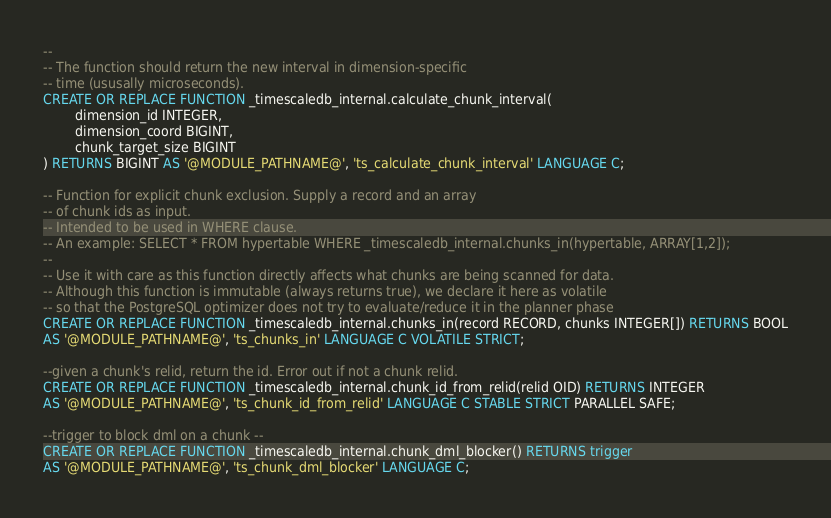<code> <loc_0><loc_0><loc_500><loc_500><_SQL_>--
-- The function should return the new interval in dimension-specific
-- time (ususally microseconds).
CREATE OR REPLACE FUNCTION _timescaledb_internal.calculate_chunk_interval(
        dimension_id INTEGER,
        dimension_coord BIGINT,
        chunk_target_size BIGINT
) RETURNS BIGINT AS '@MODULE_PATHNAME@', 'ts_calculate_chunk_interval' LANGUAGE C;

-- Function for explicit chunk exclusion. Supply a record and an array
-- of chunk ids as input.
-- Intended to be used in WHERE clause.
-- An example: SELECT * FROM hypertable WHERE _timescaledb_internal.chunks_in(hypertable, ARRAY[1,2]);
--
-- Use it with care as this function directly affects what chunks are being scanned for data.
-- Although this function is immutable (always returns true), we declare it here as volatile
-- so that the PostgreSQL optimizer does not try to evaluate/reduce it in the planner phase
CREATE OR REPLACE FUNCTION _timescaledb_internal.chunks_in(record RECORD, chunks INTEGER[]) RETURNS BOOL
AS '@MODULE_PATHNAME@', 'ts_chunks_in' LANGUAGE C VOLATILE STRICT;

--given a chunk's relid, return the id. Error out if not a chunk relid.
CREATE OR REPLACE FUNCTION _timescaledb_internal.chunk_id_from_relid(relid OID) RETURNS INTEGER
AS '@MODULE_PATHNAME@', 'ts_chunk_id_from_relid' LANGUAGE C STABLE STRICT PARALLEL SAFE;

--trigger to block dml on a chunk --
CREATE OR REPLACE FUNCTION _timescaledb_internal.chunk_dml_blocker() RETURNS trigger
AS '@MODULE_PATHNAME@', 'ts_chunk_dml_blocker' LANGUAGE C;
</code> 